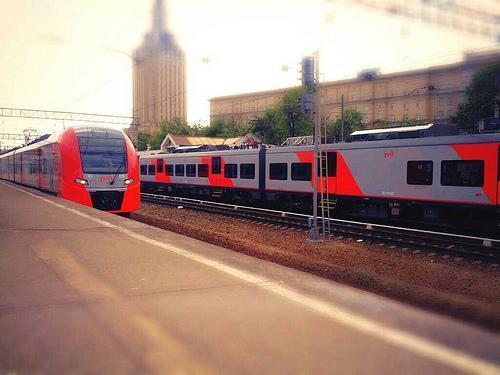How many trains are shown?
Give a very brief answer. 2. 